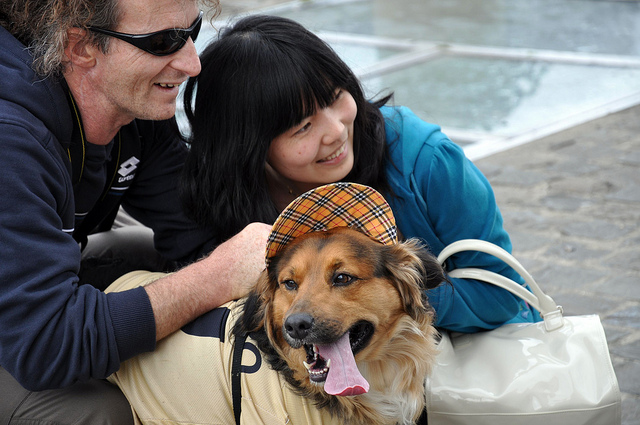<image>Why is this dog wearing a hat? I don't know why the dog is wearing a hat. Its owners could have put it on for fun or to take a picture. Why is this dog wearing a hat? I don't know why the dog is wearing a hat. It can be for various reasons such as his owners put it on him, to look cool, or for fun. 